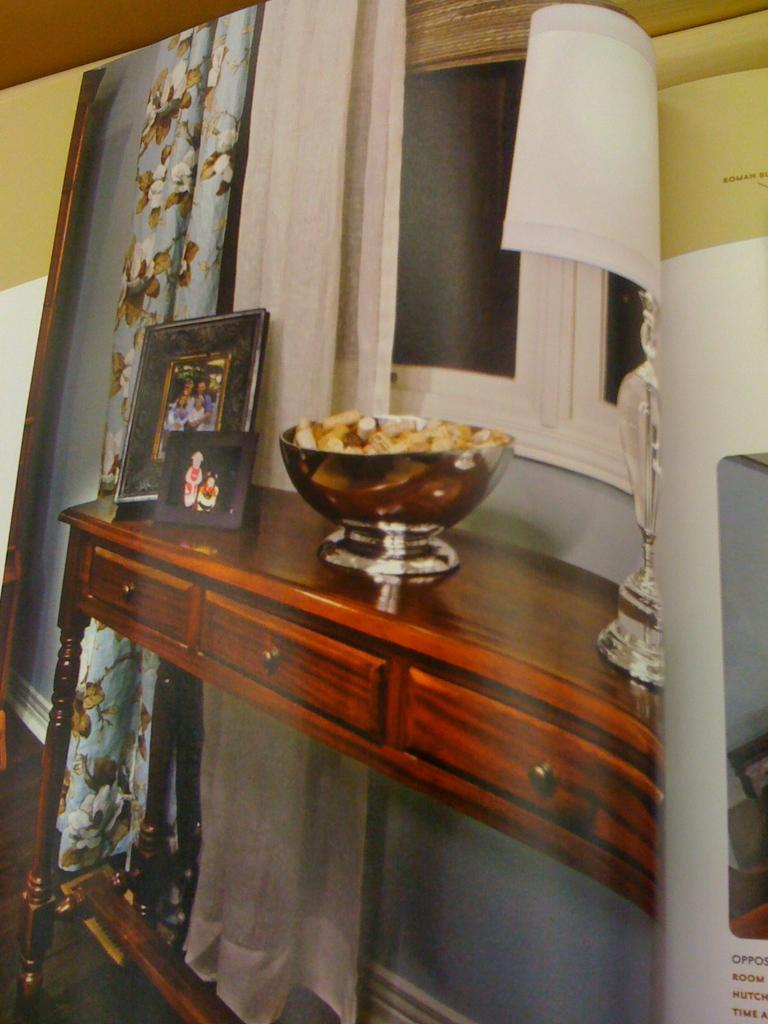What is the primary object in the image? The image contains a page. What type of furniture is present in the image? There is a desk in the image. What type of window treatment is visible in the image? There are curtains in the image. Can you describe any other items in the image? There are other items in the image, but their specific nature is not mentioned in the provided facts. What type of plot is being developed in the image? There is no plot development in the image, as it is a static representation of a page, desk, and curtains. 